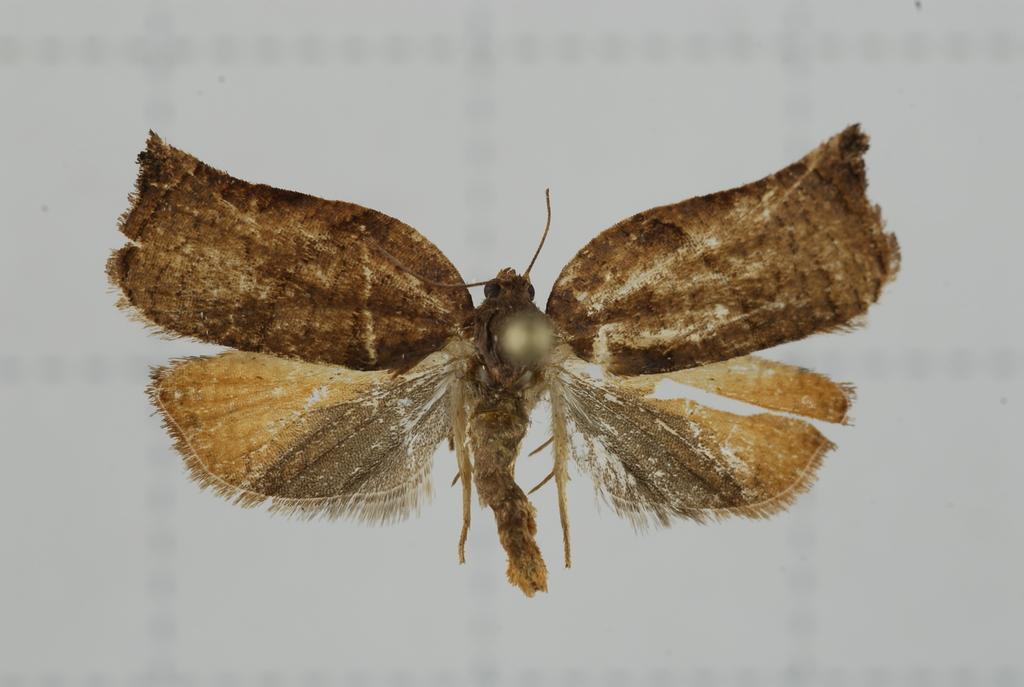Please provide a concise description of this image. In this image, I can see an insect with the wings. The background looks white in color. 